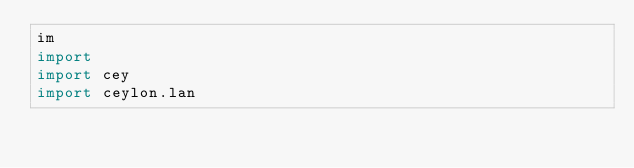Convert code to text. <code><loc_0><loc_0><loc_500><loc_500><_Ceylon_>im
import 
import cey
import ceylon.lan</code> 